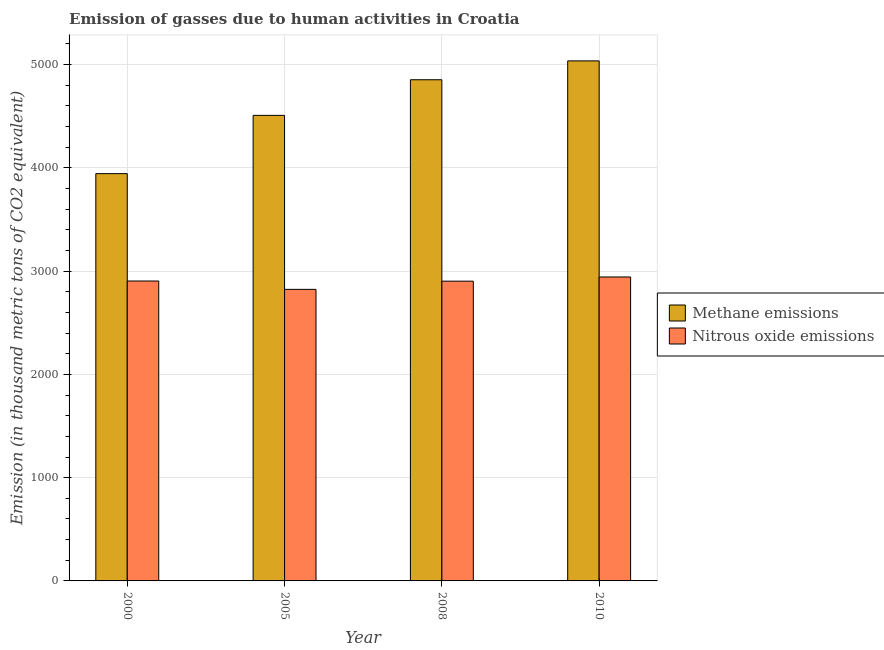How many different coloured bars are there?
Provide a short and direct response. 2. How many groups of bars are there?
Offer a very short reply. 4. Are the number of bars on each tick of the X-axis equal?
Your answer should be very brief. Yes. How many bars are there on the 2nd tick from the left?
Your answer should be very brief. 2. In how many cases, is the number of bars for a given year not equal to the number of legend labels?
Your response must be concise. 0. What is the amount of methane emissions in 2010?
Make the answer very short. 5036. Across all years, what is the maximum amount of nitrous oxide emissions?
Your answer should be compact. 2943.3. Across all years, what is the minimum amount of methane emissions?
Ensure brevity in your answer.  3944.1. In which year was the amount of nitrous oxide emissions minimum?
Keep it short and to the point. 2005. What is the total amount of nitrous oxide emissions in the graph?
Keep it short and to the point. 1.16e+04. What is the difference between the amount of methane emissions in 2008 and that in 2010?
Keep it short and to the point. -182.7. What is the difference between the amount of nitrous oxide emissions in 2008 and the amount of methane emissions in 2010?
Your answer should be compact. -40.5. What is the average amount of methane emissions per year?
Provide a succinct answer. 4585.45. In the year 2000, what is the difference between the amount of nitrous oxide emissions and amount of methane emissions?
Offer a very short reply. 0. In how many years, is the amount of nitrous oxide emissions greater than 1600 thousand metric tons?
Offer a terse response. 4. What is the ratio of the amount of methane emissions in 2000 to that in 2005?
Your answer should be compact. 0.87. Is the difference between the amount of methane emissions in 2000 and 2005 greater than the difference between the amount of nitrous oxide emissions in 2000 and 2005?
Your answer should be compact. No. What is the difference between the highest and the second highest amount of methane emissions?
Offer a terse response. 182.7. What is the difference between the highest and the lowest amount of nitrous oxide emissions?
Your response must be concise. 119.9. What does the 2nd bar from the left in 2005 represents?
Your response must be concise. Nitrous oxide emissions. What does the 2nd bar from the right in 2008 represents?
Provide a succinct answer. Methane emissions. How are the legend labels stacked?
Provide a succinct answer. Vertical. What is the title of the graph?
Offer a terse response. Emission of gasses due to human activities in Croatia. Does "Female entrants" appear as one of the legend labels in the graph?
Provide a succinct answer. No. What is the label or title of the Y-axis?
Your answer should be very brief. Emission (in thousand metric tons of CO2 equivalent). What is the Emission (in thousand metric tons of CO2 equivalent) in Methane emissions in 2000?
Offer a terse response. 3944.1. What is the Emission (in thousand metric tons of CO2 equivalent) of Nitrous oxide emissions in 2000?
Offer a very short reply. 2904.3. What is the Emission (in thousand metric tons of CO2 equivalent) of Methane emissions in 2005?
Offer a very short reply. 4508.4. What is the Emission (in thousand metric tons of CO2 equivalent) of Nitrous oxide emissions in 2005?
Your response must be concise. 2823.4. What is the Emission (in thousand metric tons of CO2 equivalent) in Methane emissions in 2008?
Make the answer very short. 4853.3. What is the Emission (in thousand metric tons of CO2 equivalent) in Nitrous oxide emissions in 2008?
Keep it short and to the point. 2902.8. What is the Emission (in thousand metric tons of CO2 equivalent) in Methane emissions in 2010?
Give a very brief answer. 5036. What is the Emission (in thousand metric tons of CO2 equivalent) of Nitrous oxide emissions in 2010?
Keep it short and to the point. 2943.3. Across all years, what is the maximum Emission (in thousand metric tons of CO2 equivalent) in Methane emissions?
Ensure brevity in your answer.  5036. Across all years, what is the maximum Emission (in thousand metric tons of CO2 equivalent) in Nitrous oxide emissions?
Keep it short and to the point. 2943.3. Across all years, what is the minimum Emission (in thousand metric tons of CO2 equivalent) of Methane emissions?
Ensure brevity in your answer.  3944.1. Across all years, what is the minimum Emission (in thousand metric tons of CO2 equivalent) in Nitrous oxide emissions?
Offer a very short reply. 2823.4. What is the total Emission (in thousand metric tons of CO2 equivalent) of Methane emissions in the graph?
Ensure brevity in your answer.  1.83e+04. What is the total Emission (in thousand metric tons of CO2 equivalent) in Nitrous oxide emissions in the graph?
Ensure brevity in your answer.  1.16e+04. What is the difference between the Emission (in thousand metric tons of CO2 equivalent) of Methane emissions in 2000 and that in 2005?
Make the answer very short. -564.3. What is the difference between the Emission (in thousand metric tons of CO2 equivalent) of Nitrous oxide emissions in 2000 and that in 2005?
Offer a terse response. 80.9. What is the difference between the Emission (in thousand metric tons of CO2 equivalent) in Methane emissions in 2000 and that in 2008?
Provide a short and direct response. -909.2. What is the difference between the Emission (in thousand metric tons of CO2 equivalent) of Methane emissions in 2000 and that in 2010?
Your response must be concise. -1091.9. What is the difference between the Emission (in thousand metric tons of CO2 equivalent) of Nitrous oxide emissions in 2000 and that in 2010?
Ensure brevity in your answer.  -39. What is the difference between the Emission (in thousand metric tons of CO2 equivalent) of Methane emissions in 2005 and that in 2008?
Give a very brief answer. -344.9. What is the difference between the Emission (in thousand metric tons of CO2 equivalent) in Nitrous oxide emissions in 2005 and that in 2008?
Make the answer very short. -79.4. What is the difference between the Emission (in thousand metric tons of CO2 equivalent) of Methane emissions in 2005 and that in 2010?
Give a very brief answer. -527.6. What is the difference between the Emission (in thousand metric tons of CO2 equivalent) of Nitrous oxide emissions in 2005 and that in 2010?
Provide a succinct answer. -119.9. What is the difference between the Emission (in thousand metric tons of CO2 equivalent) of Methane emissions in 2008 and that in 2010?
Provide a succinct answer. -182.7. What is the difference between the Emission (in thousand metric tons of CO2 equivalent) of Nitrous oxide emissions in 2008 and that in 2010?
Your answer should be very brief. -40.5. What is the difference between the Emission (in thousand metric tons of CO2 equivalent) of Methane emissions in 2000 and the Emission (in thousand metric tons of CO2 equivalent) of Nitrous oxide emissions in 2005?
Your answer should be very brief. 1120.7. What is the difference between the Emission (in thousand metric tons of CO2 equivalent) of Methane emissions in 2000 and the Emission (in thousand metric tons of CO2 equivalent) of Nitrous oxide emissions in 2008?
Give a very brief answer. 1041.3. What is the difference between the Emission (in thousand metric tons of CO2 equivalent) of Methane emissions in 2000 and the Emission (in thousand metric tons of CO2 equivalent) of Nitrous oxide emissions in 2010?
Your response must be concise. 1000.8. What is the difference between the Emission (in thousand metric tons of CO2 equivalent) in Methane emissions in 2005 and the Emission (in thousand metric tons of CO2 equivalent) in Nitrous oxide emissions in 2008?
Make the answer very short. 1605.6. What is the difference between the Emission (in thousand metric tons of CO2 equivalent) of Methane emissions in 2005 and the Emission (in thousand metric tons of CO2 equivalent) of Nitrous oxide emissions in 2010?
Provide a succinct answer. 1565.1. What is the difference between the Emission (in thousand metric tons of CO2 equivalent) in Methane emissions in 2008 and the Emission (in thousand metric tons of CO2 equivalent) in Nitrous oxide emissions in 2010?
Your response must be concise. 1910. What is the average Emission (in thousand metric tons of CO2 equivalent) of Methane emissions per year?
Make the answer very short. 4585.45. What is the average Emission (in thousand metric tons of CO2 equivalent) in Nitrous oxide emissions per year?
Your answer should be very brief. 2893.45. In the year 2000, what is the difference between the Emission (in thousand metric tons of CO2 equivalent) in Methane emissions and Emission (in thousand metric tons of CO2 equivalent) in Nitrous oxide emissions?
Ensure brevity in your answer.  1039.8. In the year 2005, what is the difference between the Emission (in thousand metric tons of CO2 equivalent) in Methane emissions and Emission (in thousand metric tons of CO2 equivalent) in Nitrous oxide emissions?
Offer a terse response. 1685. In the year 2008, what is the difference between the Emission (in thousand metric tons of CO2 equivalent) in Methane emissions and Emission (in thousand metric tons of CO2 equivalent) in Nitrous oxide emissions?
Your response must be concise. 1950.5. In the year 2010, what is the difference between the Emission (in thousand metric tons of CO2 equivalent) of Methane emissions and Emission (in thousand metric tons of CO2 equivalent) of Nitrous oxide emissions?
Your answer should be very brief. 2092.7. What is the ratio of the Emission (in thousand metric tons of CO2 equivalent) of Methane emissions in 2000 to that in 2005?
Your response must be concise. 0.87. What is the ratio of the Emission (in thousand metric tons of CO2 equivalent) of Nitrous oxide emissions in 2000 to that in 2005?
Provide a succinct answer. 1.03. What is the ratio of the Emission (in thousand metric tons of CO2 equivalent) of Methane emissions in 2000 to that in 2008?
Give a very brief answer. 0.81. What is the ratio of the Emission (in thousand metric tons of CO2 equivalent) of Methane emissions in 2000 to that in 2010?
Provide a short and direct response. 0.78. What is the ratio of the Emission (in thousand metric tons of CO2 equivalent) of Nitrous oxide emissions in 2000 to that in 2010?
Keep it short and to the point. 0.99. What is the ratio of the Emission (in thousand metric tons of CO2 equivalent) in Methane emissions in 2005 to that in 2008?
Make the answer very short. 0.93. What is the ratio of the Emission (in thousand metric tons of CO2 equivalent) in Nitrous oxide emissions in 2005 to that in 2008?
Make the answer very short. 0.97. What is the ratio of the Emission (in thousand metric tons of CO2 equivalent) of Methane emissions in 2005 to that in 2010?
Offer a terse response. 0.9. What is the ratio of the Emission (in thousand metric tons of CO2 equivalent) of Nitrous oxide emissions in 2005 to that in 2010?
Offer a terse response. 0.96. What is the ratio of the Emission (in thousand metric tons of CO2 equivalent) in Methane emissions in 2008 to that in 2010?
Provide a short and direct response. 0.96. What is the ratio of the Emission (in thousand metric tons of CO2 equivalent) of Nitrous oxide emissions in 2008 to that in 2010?
Provide a succinct answer. 0.99. What is the difference between the highest and the second highest Emission (in thousand metric tons of CO2 equivalent) in Methane emissions?
Ensure brevity in your answer.  182.7. What is the difference between the highest and the second highest Emission (in thousand metric tons of CO2 equivalent) of Nitrous oxide emissions?
Ensure brevity in your answer.  39. What is the difference between the highest and the lowest Emission (in thousand metric tons of CO2 equivalent) of Methane emissions?
Your answer should be very brief. 1091.9. What is the difference between the highest and the lowest Emission (in thousand metric tons of CO2 equivalent) of Nitrous oxide emissions?
Your answer should be very brief. 119.9. 